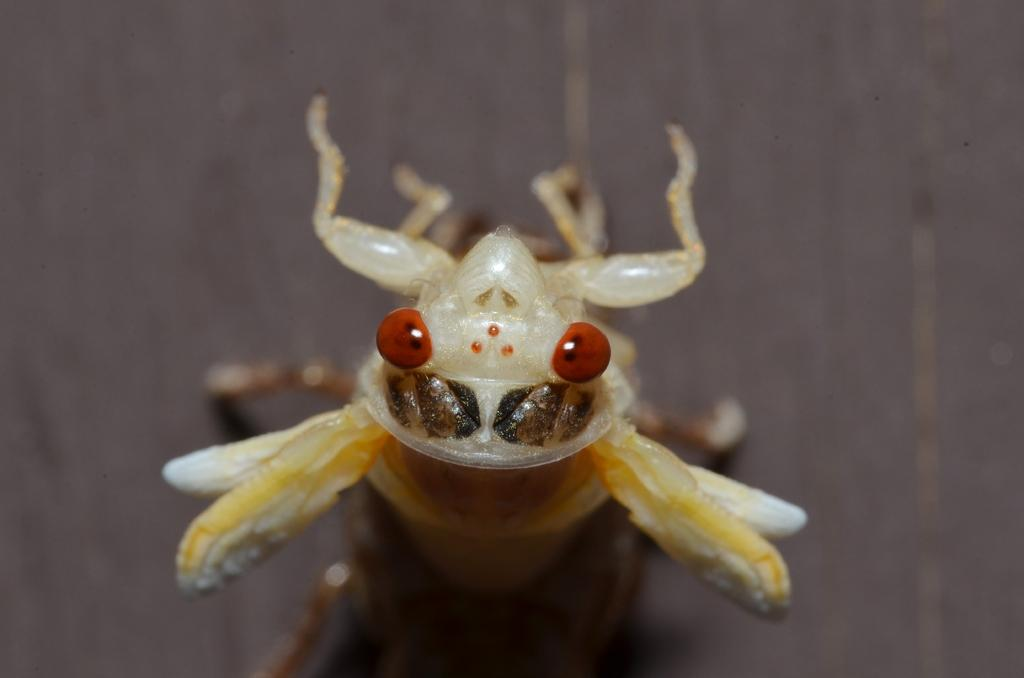What is the main subject of the picture? The main subject of the picture is an insect. Can you describe the color of the insect? The insect is cream-colored. How would you describe the background of the image? The background of the image is blurred. In which direction is the hat leaning in the image? There is no hat present in the image. Can you tell me how many times the insect has been crushed in the image? There is no indication in the image that the insect has been crushed. 